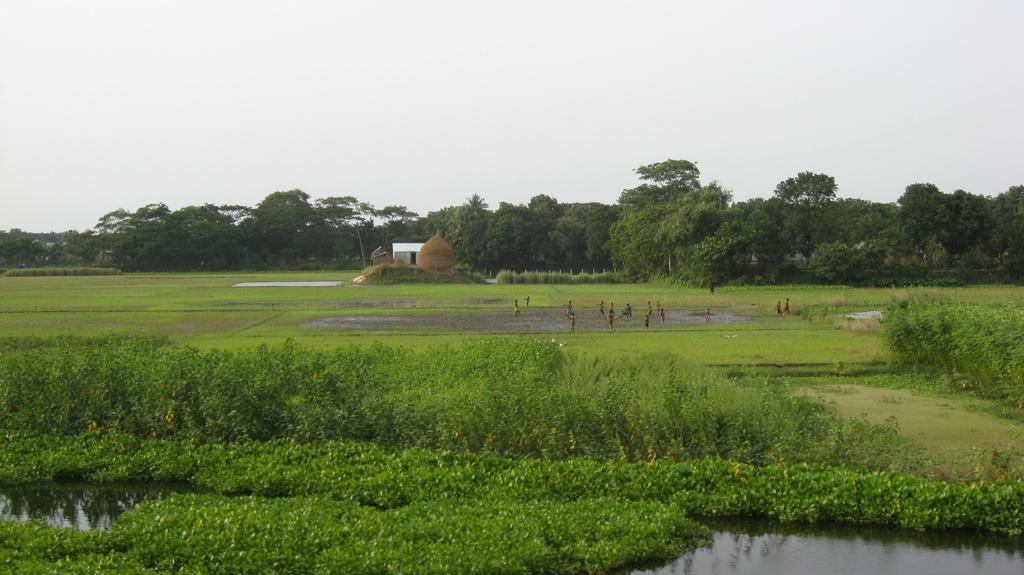Describe this image in one or two sentences. In this image I can see plants, grass, water and a group of people in the farm. In the background I can see trees, houses, fence and the sky. This image is taken may be in a farm during a day. 